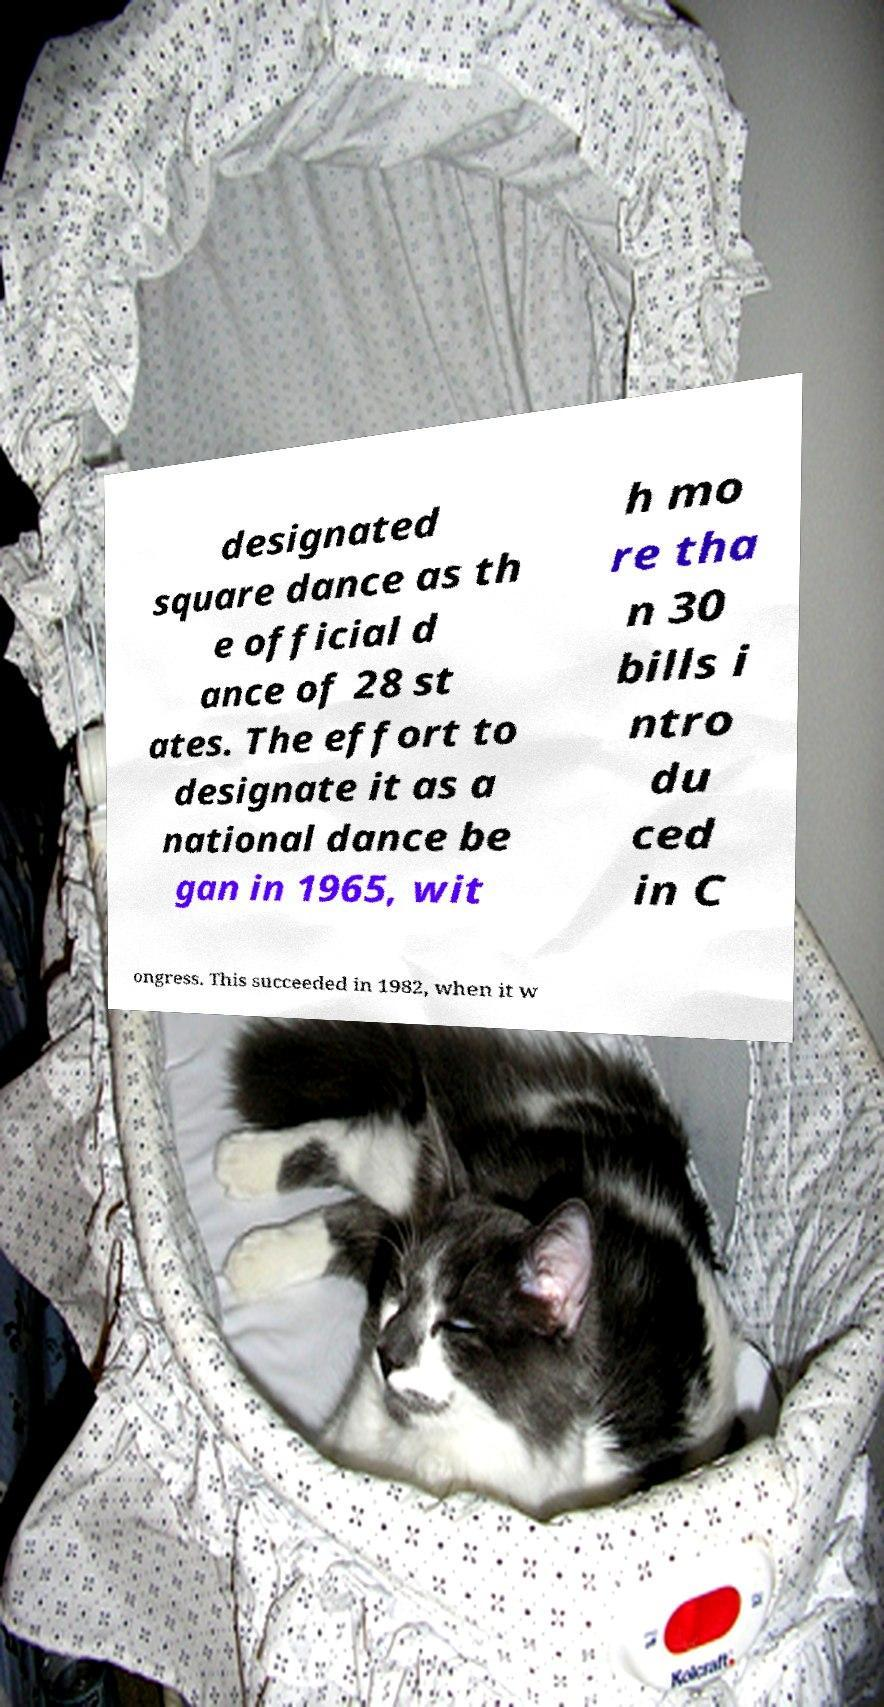For documentation purposes, I need the text within this image transcribed. Could you provide that? designated square dance as th e official d ance of 28 st ates. The effort to designate it as a national dance be gan in 1965, wit h mo re tha n 30 bills i ntro du ced in C ongress. This succeeded in 1982, when it w 